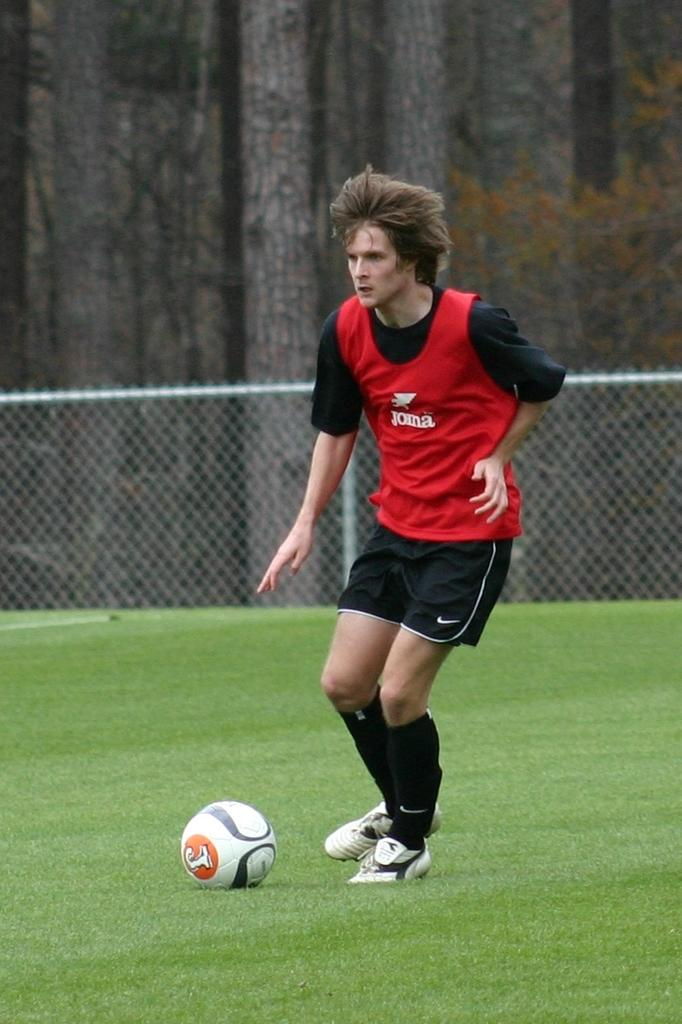What is the man in the image doing? The man is playing football in the image. What object is on the ground that is related to the activity the man is doing? There is a football on the ground. What type of barrier can be seen in the image? There is a metal fence in the image. What type of vegetation is visible in the image? Trees are present in the image. What type of ground surface is visible in the image? Grass is visible on the ground in the image. What type of tools is the carpenter using at the party in the image? There is no carpenter or party present in the image. Is there an umbrella being used by the man playing football in the image? There is no umbrella visible in the image; the man is playing football in the open grass area. 